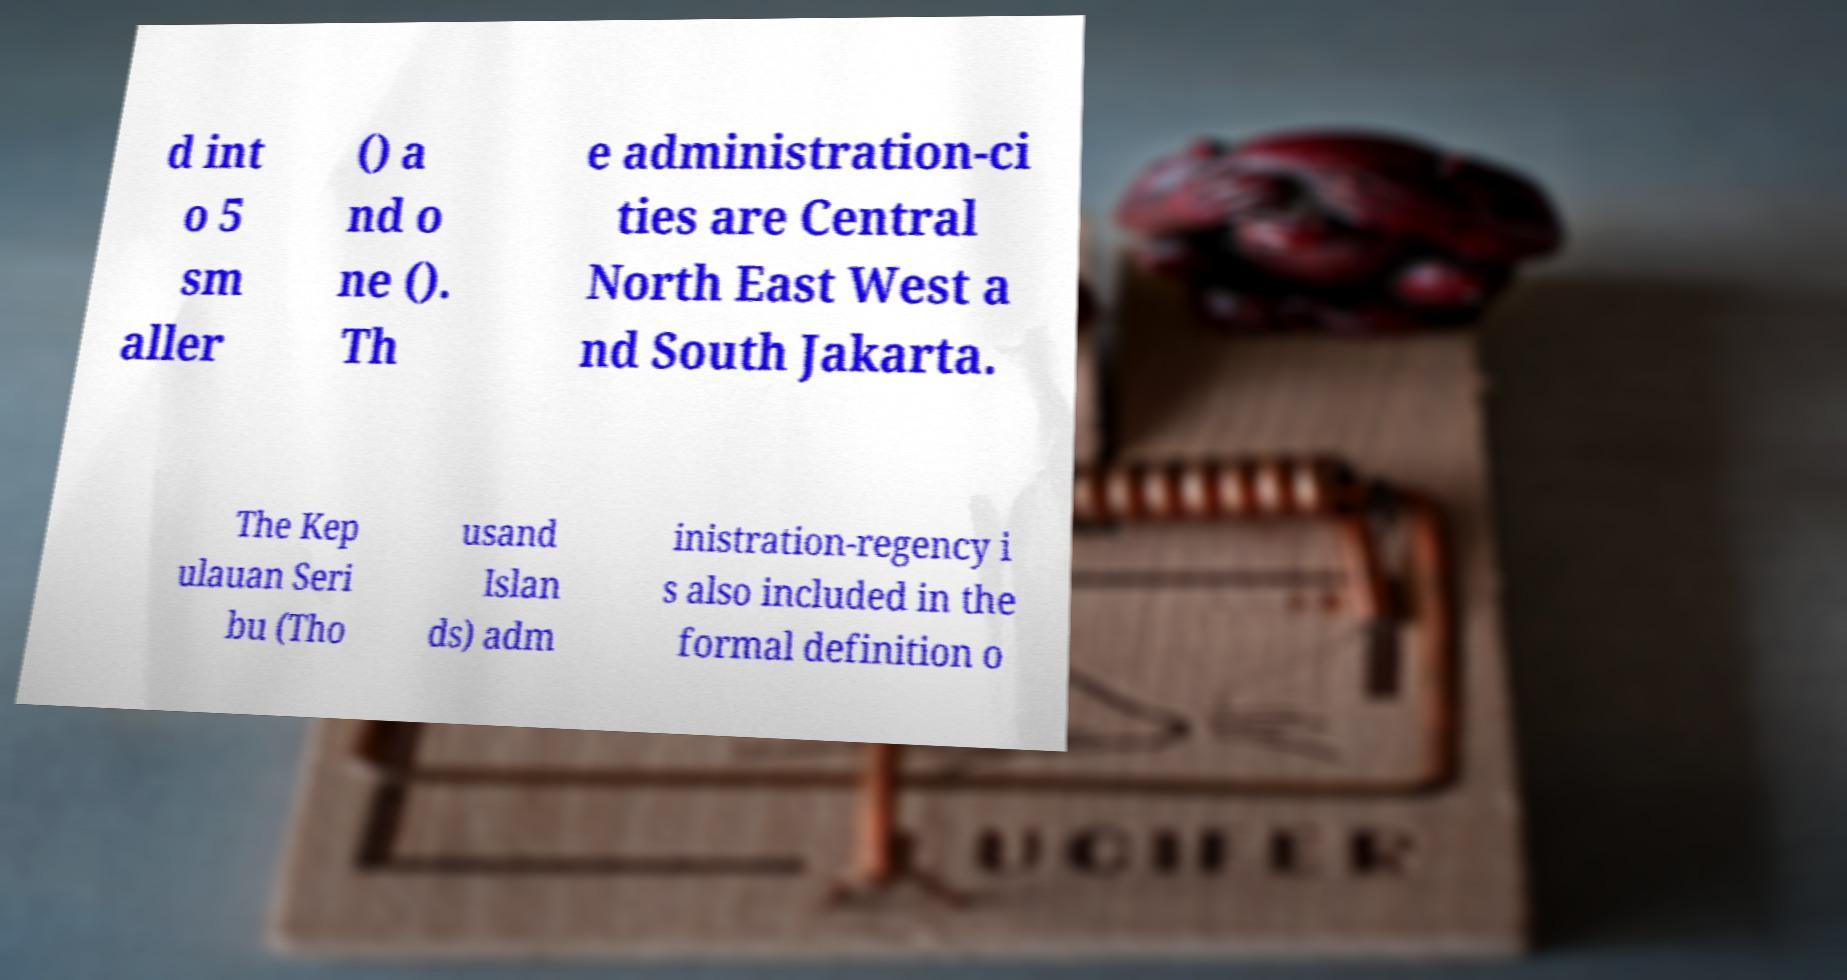I need the written content from this picture converted into text. Can you do that? d int o 5 sm aller () a nd o ne (). Th e administration-ci ties are Central North East West a nd South Jakarta. The Kep ulauan Seri bu (Tho usand Islan ds) adm inistration-regency i s also included in the formal definition o 